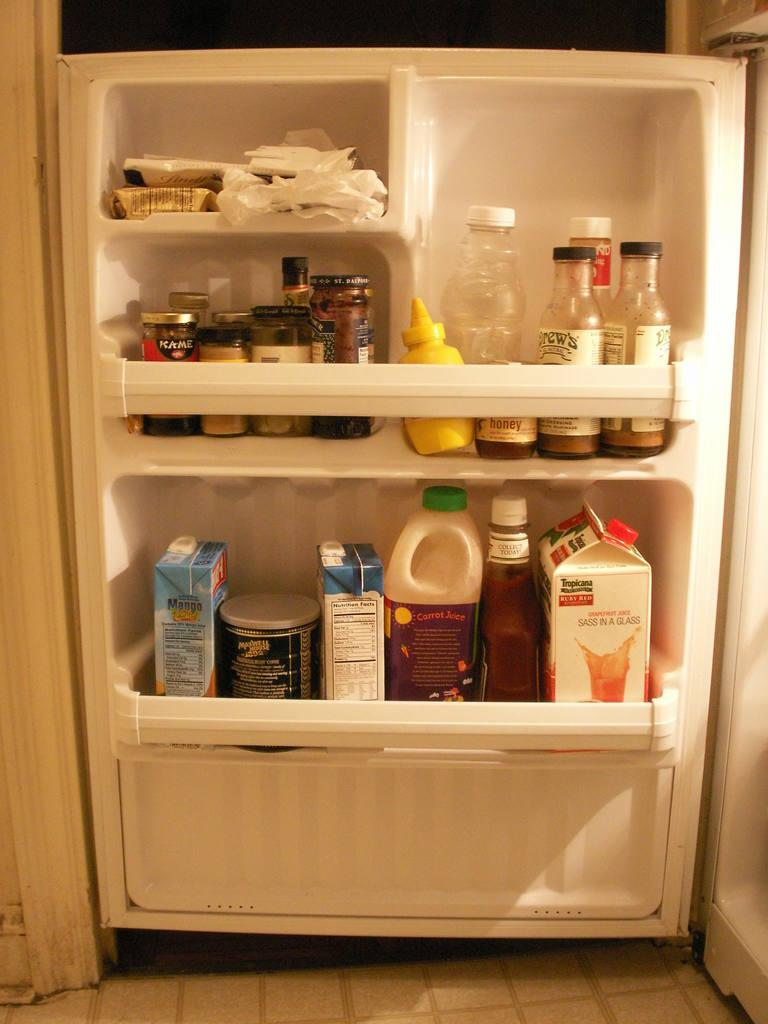<image>
Render a clear and concise summary of the photo. One of the many items in the refrigerator door is a carton of Tropicana grapefruit juice. 